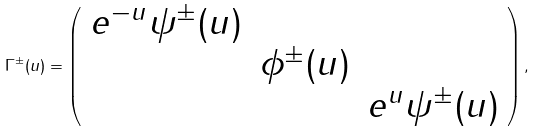<formula> <loc_0><loc_0><loc_500><loc_500>\Gamma ^ { \pm } ( u ) = \left ( \begin{array} { c c c } e ^ { - u } \psi ^ { \pm } ( u ) & & \\ & \phi ^ { \pm } ( u ) & \\ & & e ^ { u } \psi ^ { \pm } ( u ) \end{array} \right ) ,</formula> 